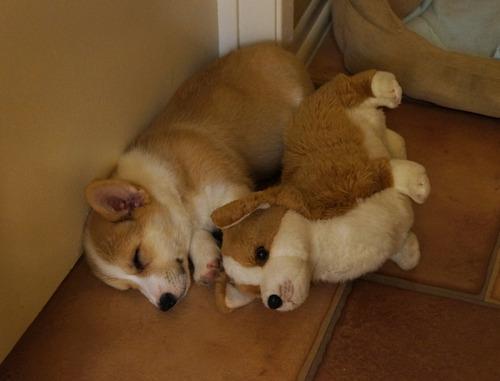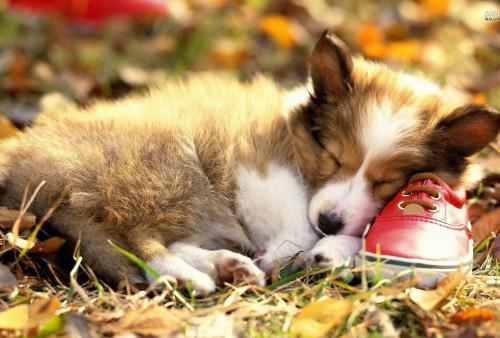The first image is the image on the left, the second image is the image on the right. Analyze the images presented: Is the assertion "A dog is sleeping beside a stuffed toy." valid? Answer yes or no. Yes. The first image is the image on the left, the second image is the image on the right. Given the left and right images, does the statement "One dog is sleeping with a stuffed animal." hold true? Answer yes or no. Yes. 